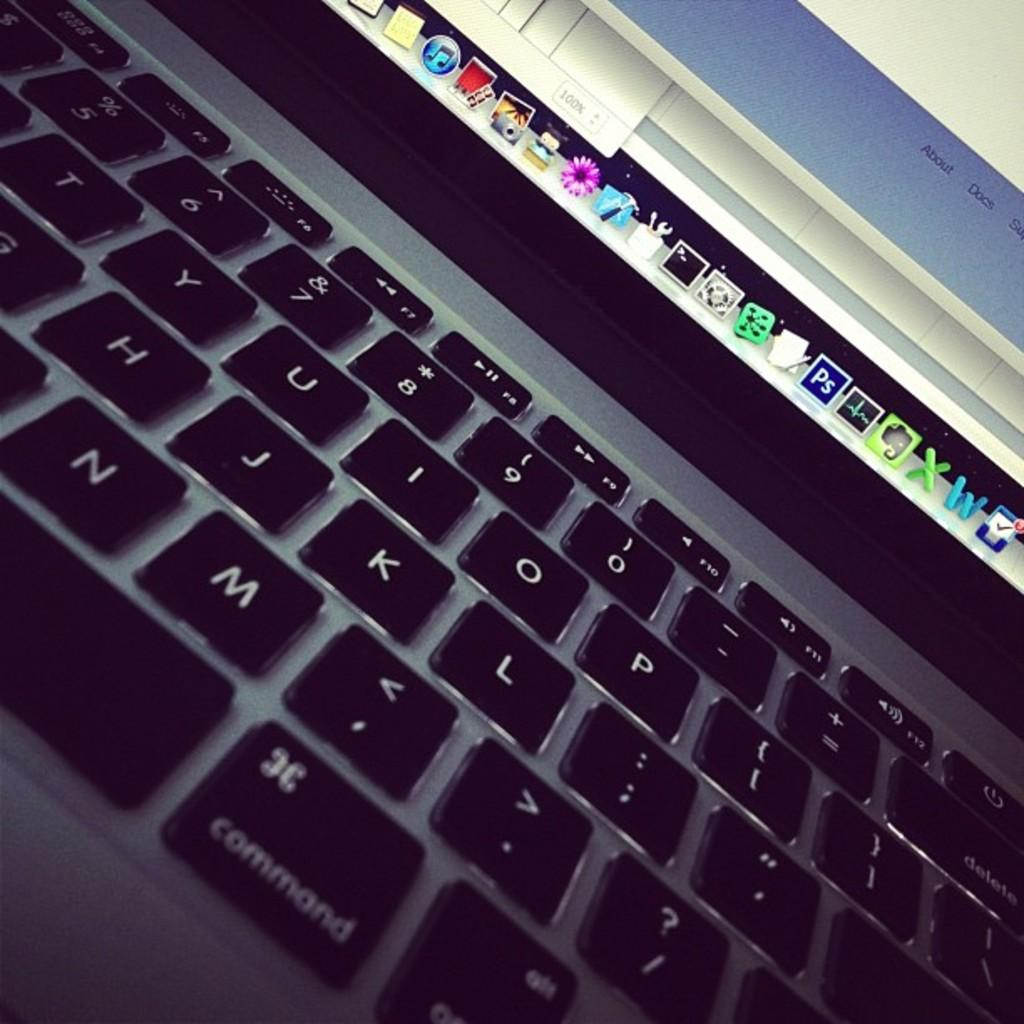<image>
Relay a brief, clear account of the picture shown. The keyboard of a laptop includes a command button. 